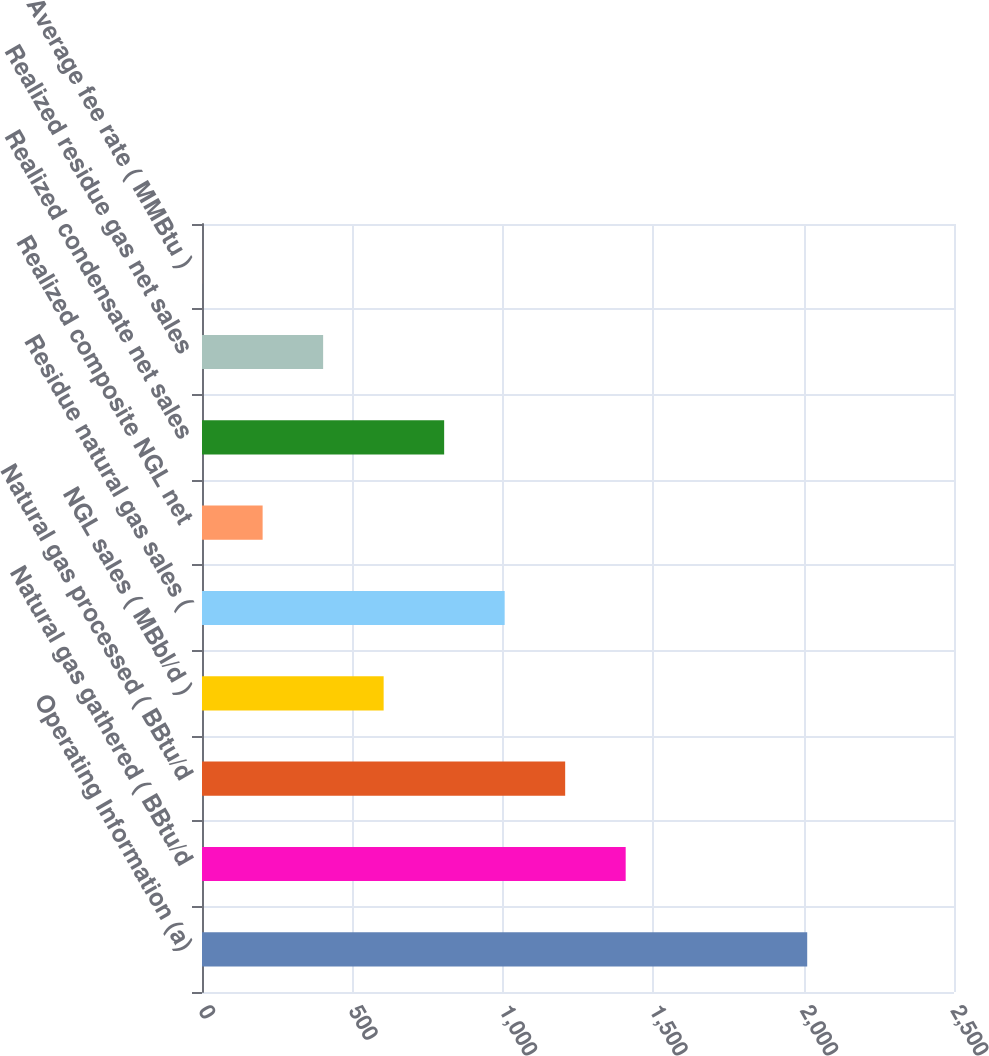Convert chart. <chart><loc_0><loc_0><loc_500><loc_500><bar_chart><fcel>Operating Information (a)<fcel>Natural gas gathered ( BBtu/d<fcel>Natural gas processed ( BBtu/d<fcel>NGL sales ( MBbl/d )<fcel>Residue natural gas sales (<fcel>Realized composite NGL net<fcel>Realized condensate net sales<fcel>Realized residue gas net sales<fcel>Average fee rate ( MMBtu )<nl><fcel>2012<fcel>1408.52<fcel>1207.36<fcel>603.86<fcel>1006.19<fcel>201.52<fcel>805.03<fcel>402.69<fcel>0.35<nl></chart> 